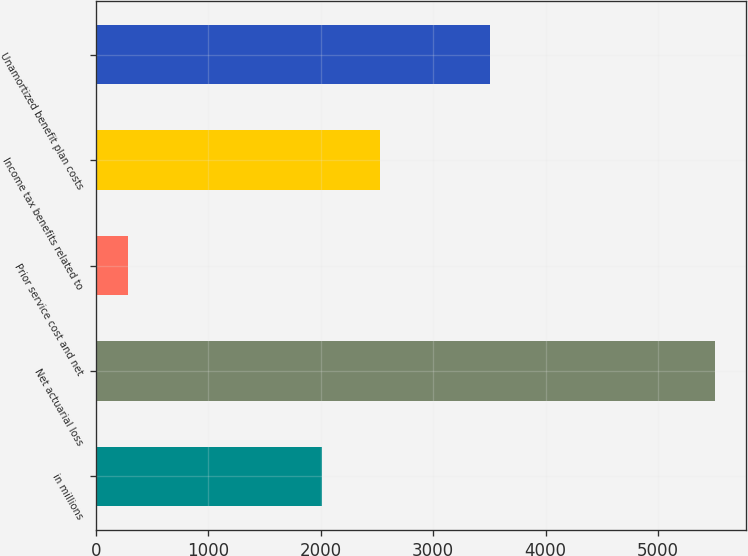<chart> <loc_0><loc_0><loc_500><loc_500><bar_chart><fcel>in millions<fcel>Net actuarial loss<fcel>Prior service cost and net<fcel>Income tax benefits related to<fcel>Unamortized benefit plan costs<nl><fcel>2008<fcel>5509<fcel>287<fcel>2530.2<fcel>3510<nl></chart> 